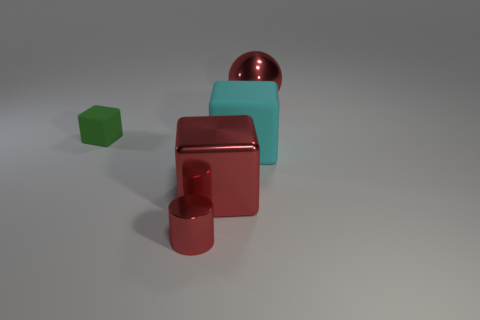There is a large object that is the same color as the shiny sphere; what is it made of?
Provide a short and direct response. Metal. Is the color of the small cylinder the same as the large rubber thing?
Provide a short and direct response. No. There is a large metal object that is behind the tiny object that is left of the red cylinder; what shape is it?
Your answer should be very brief. Sphere. Is the big red cube made of the same material as the green block?
Give a very brief answer. No. What is the shape of the small object that is the same material as the big red ball?
Keep it short and to the point. Cylinder. Is there any other thing that has the same color as the big ball?
Provide a succinct answer. Yes. There is a block that is left of the small metal cylinder; what is its color?
Your response must be concise. Green. Is the color of the thing left of the metallic cylinder the same as the large ball?
Offer a terse response. No. There is a big cyan thing that is the same shape as the small rubber thing; what is its material?
Your response must be concise. Rubber. What number of shiny balls are the same size as the cylinder?
Offer a terse response. 0. 